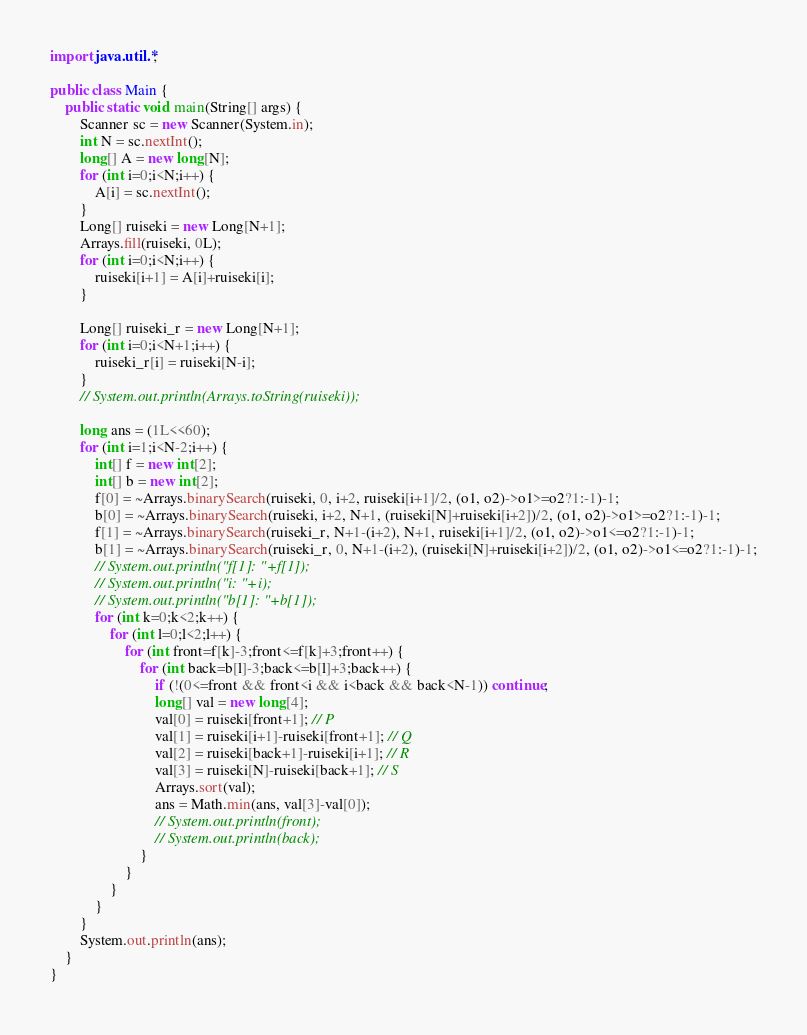Convert code to text. <code><loc_0><loc_0><loc_500><loc_500><_Java_>import java.util.*;

public class Main {
    public static void main(String[] args) {
        Scanner sc = new Scanner(System.in);
        int N = sc.nextInt();
        long[] A = new long[N];
        for (int i=0;i<N;i++) {
            A[i] = sc.nextInt();
        }
        Long[] ruiseki = new Long[N+1];
        Arrays.fill(ruiseki, 0L);
        for (int i=0;i<N;i++) {
            ruiseki[i+1] = A[i]+ruiseki[i];
        }

        Long[] ruiseki_r = new Long[N+1];
        for (int i=0;i<N+1;i++) {
            ruiseki_r[i] = ruiseki[N-i];
        }
        // System.out.println(Arrays.toString(ruiseki));

        long ans = (1L<<60);
        for (int i=1;i<N-2;i++) {
            int[] f = new int[2];
            int[] b = new int[2];
            f[0] = ~Arrays.binarySearch(ruiseki, 0, i+2, ruiseki[i+1]/2, (o1, o2)->o1>=o2?1:-1)-1;
            b[0] = ~Arrays.binarySearch(ruiseki, i+2, N+1, (ruiseki[N]+ruiseki[i+2])/2, (o1, o2)->o1>=o2?1:-1)-1;
            f[1] = ~Arrays.binarySearch(ruiseki_r, N+1-(i+2), N+1, ruiseki[i+1]/2, (o1, o2)->o1<=o2?1:-1)-1;
            b[1] = ~Arrays.binarySearch(ruiseki_r, 0, N+1-(i+2), (ruiseki[N]+ruiseki[i+2])/2, (o1, o2)->o1<=o2?1:-1)-1;
            // System.out.println("f[1]: "+f[1]);
            // System.out.println("i: "+i);
            // System.out.println("b[1]: "+b[1]);
            for (int k=0;k<2;k++) {
                for (int l=0;l<2;l++) {
                    for (int front=f[k]-3;front<=f[k]+3;front++) {
                        for (int back=b[l]-3;back<=b[l]+3;back++) {
                            if (!(0<=front && front<i && i<back && back<N-1)) continue;
                            long[] val = new long[4];
                            val[0] = ruiseki[front+1]; // P
                            val[1] = ruiseki[i+1]-ruiseki[front+1]; // Q
                            val[2] = ruiseki[back+1]-ruiseki[i+1]; // R
                            val[3] = ruiseki[N]-ruiseki[back+1]; // S
                            Arrays.sort(val);
                            ans = Math.min(ans, val[3]-val[0]);
                            // System.out.println(front);
                            // System.out.println(back);
                        }
                    }
                }
            }
        }
        System.out.println(ans);
    }
}</code> 